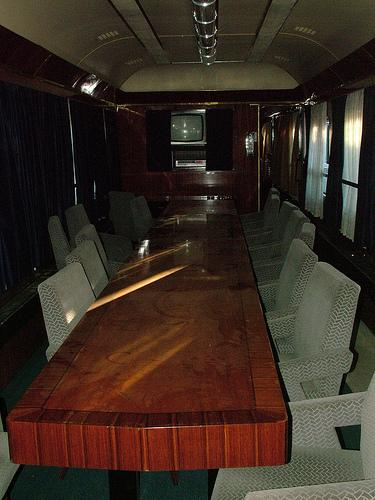What are the prominent colors of the curtains visible in the windows of the train car? The curtains on the windows are predominantly sheer white, dark blue, and black. Provide a brief description of the type of room the image showcases. The image showcases a train car with a long wooden conference table surrounded by chairs and a television mounted on the wall. Count the number of objects mentioned in the image that are related to the table's support and construction. Three objects are mentioned related to the table's support and construction: a leg, a support post, and a decorative end. How would you characterize the chairs around the conference table in terms of design? The chairs around the conference table are gray, patterned, and appear to have arms. Describe the "small details" in the image, such as decorations or accessories. Details include a gold pole in front of the table, a video player under the television, a cross beam on the window, and air vents in the train car. List three prominent features of the conference table in the image. The conference table is wooden, brown, and quite long, with some visible dust on its surface. Explain the purpose of this particular train car based on the image. The purpose of this train car is to provide a space for meetings or conferences, facilitated by a large table, chairs, and a television for presentations. Provide an observation about the cleanliness of the train car. The train car seems to have a slightly dusty ambiance, as there is dust on the wood table surfaces. In a few words, describe the lighting situation in the train car. Sunlight beams through the windows, creating reflections on the table, and there is also overhead lighting. What type of electronic device is positioned near the end of the conference table? A television is mounted on the wall near the end of the conference table. Are there any purple air vents in the train car? There is an air vent mentioned in the image, but it is not described as purple. The color of the air vent is not mentioned at all. Is there an orange chair around the table? There are chairs mentioned in the image, but none of them are described as orange. Some chairs are described as gray with a pattern or white, but not orange. Is there a small round table in the image? The only table mentioned in the image is long, wooden, and a conference-style table. There is no mention of a small or round table. Can you see a modern flat screen TV mounted on the wall? There is an old-fashioned TV and a television mentioned in the image, but none of them are described as modern or flat screen. Can you find red curtains on the windows? The curtains mentioned in the image are white, dark blue, sheer white, and black. There is no mention of red curtains. Is there a green wooden table in the image? No, it's not mentioned in the image. 